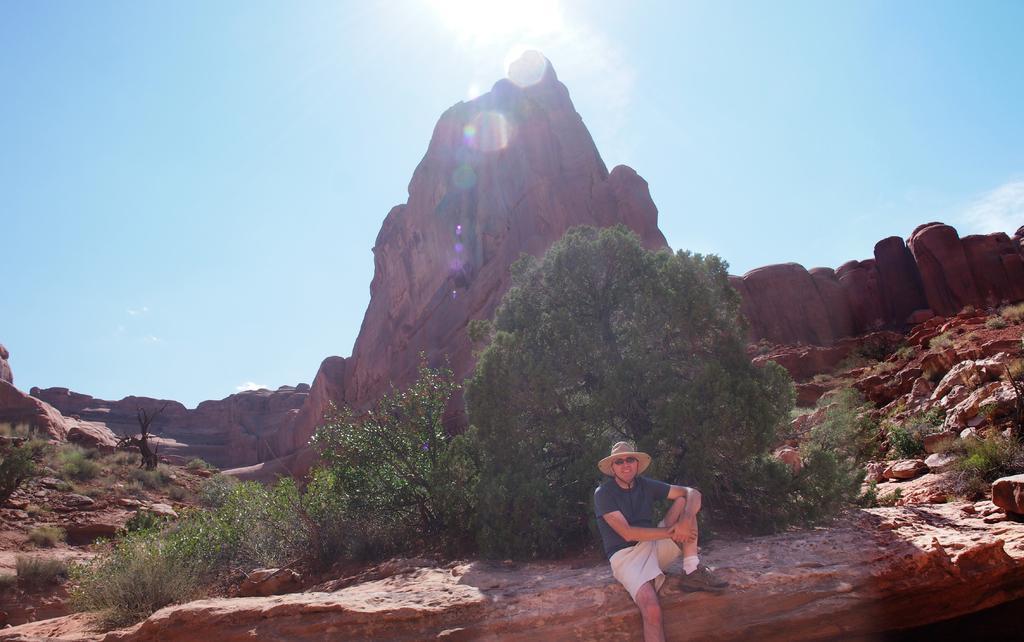Describe this image in one or two sentences. In this image in front there is a person sitting. Behind him there are trees. In the background of the image there are rocks and sky. 